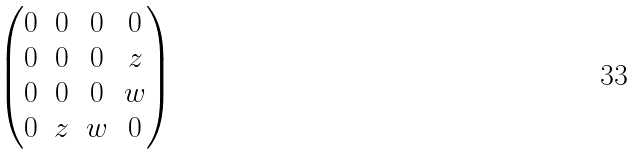Convert formula to latex. <formula><loc_0><loc_0><loc_500><loc_500>\begin{pmatrix} 0 & 0 & 0 & 0 \\ 0 & 0 & 0 & z \\ 0 & 0 & 0 & w \\ 0 & z & w & 0 \\ \end{pmatrix}</formula> 